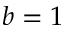Convert formula to latex. <formula><loc_0><loc_0><loc_500><loc_500>b = 1</formula> 